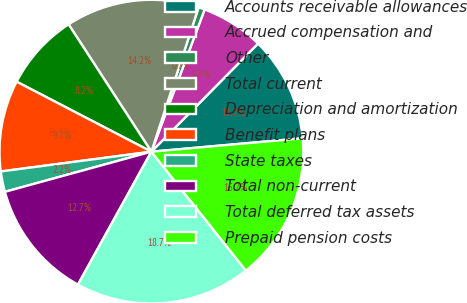Convert chart. <chart><loc_0><loc_0><loc_500><loc_500><pie_chart><fcel>Accounts receivable allowances<fcel>Accrued compensation and<fcel>Other<fcel>Total current<fcel>Depreciation and amortization<fcel>Benefit plans<fcel>State taxes<fcel>Total non-current<fcel>Total deferred tax assets<fcel>Prepaid pension costs<nl><fcel>11.2%<fcel>6.69%<fcel>0.67%<fcel>14.21%<fcel>8.2%<fcel>9.7%<fcel>2.18%<fcel>12.71%<fcel>18.72%<fcel>15.72%<nl></chart> 